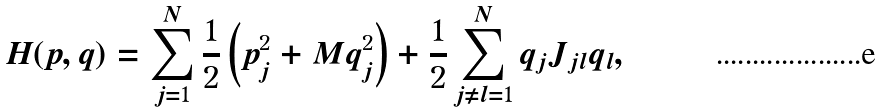Convert formula to latex. <formula><loc_0><loc_0><loc_500><loc_500>H ( p , q ) = \sum _ { j = 1 } ^ { N } \frac { 1 } { 2 } \left ( p _ { j } ^ { 2 } + M q _ { j } ^ { 2 } \right ) + \frac { 1 } { 2 } \sum _ { j \neq l = 1 } ^ { N } q _ { j } J _ { j l } q _ { l } ,</formula> 